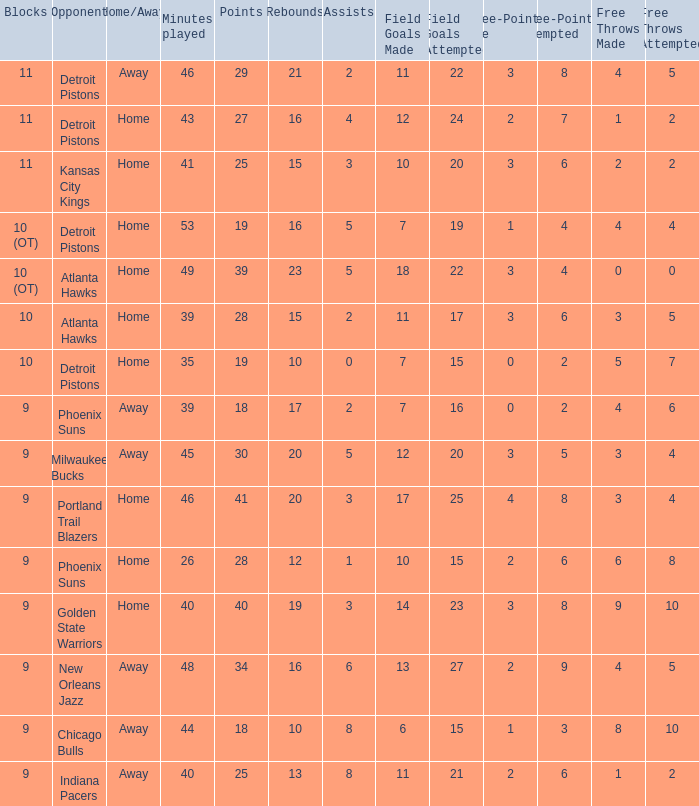How many points were there when there were less than 16 rebounds and 5 assists? 0.0. 